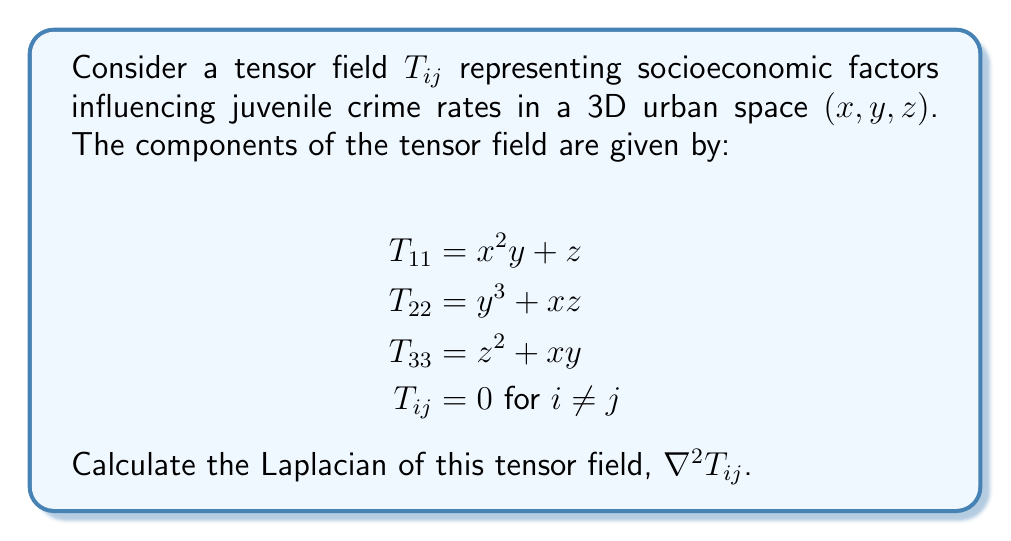Teach me how to tackle this problem. To evaluate the Laplacian of the tensor field, we need to follow these steps:

1) The Laplacian of a tensor field is defined as the sum of the second partial derivatives with respect to each coordinate:

   $$\nabla^2 T_{ij} = \frac{\partial^2 T_{ij}}{\partial x^2} + \frac{\partial^2 T_{ij}}{\partial y^2} + \frac{\partial^2 T_{ij}}{\partial z^2}$$

2) Let's calculate this for each non-zero component:

   For $T_{11}$:
   $$\frac{\partial^2 T_{11}}{\partial x^2} = 0$$
   $$\frac{\partial^2 T_{11}}{\partial y^2} = 2$$
   $$\frac{\partial^2 T_{11}}{\partial z^2} = 0$$
   
   Therefore, $\nabla^2 T_{11} = 0 + 2 + 0 = 2$

   For $T_{22}$:
   $$\frac{\partial^2 T_{22}}{\partial x^2} = 0$$
   $$\frac{\partial^2 T_{22}}{\partial y^2} = 6y$$
   $$\frac{\partial^2 T_{22}}{\partial z^2} = 0$$
   
   Therefore, $\nabla^2 T_{22} = 0 + 6y + 0 = 6y$

   For $T_{33}$:
   $$\frac{\partial^2 T_{33}}{\partial x^2} = 0$$
   $$\frac{\partial^2 T_{33}}{\partial y^2} = 0$$
   $$\frac{\partial^2 T_{33}}{\partial z^2} = 2$$
   
   Therefore, $\nabla^2 T_{33} = 0 + 0 + 2 = 2$

3) For all other components ($i \neq j$), $T_{ij} = 0$, so $\nabla^2 T_{ij} = 0$

4) We can now write the Laplacian of the tensor field as a new tensor:

   $$\nabla^2 T_{ij} = \begin{pmatrix}
   2 & 0 & 0 \\
   0 & 6y & 0 \\
   0 & 0 & 2
   \end{pmatrix}$$
Answer: $$\nabla^2 T_{ij} = \begin{pmatrix}
2 & 0 & 0 \\
0 & 6y & 0 \\
0 & 0 & 2
\end{pmatrix}$$ 